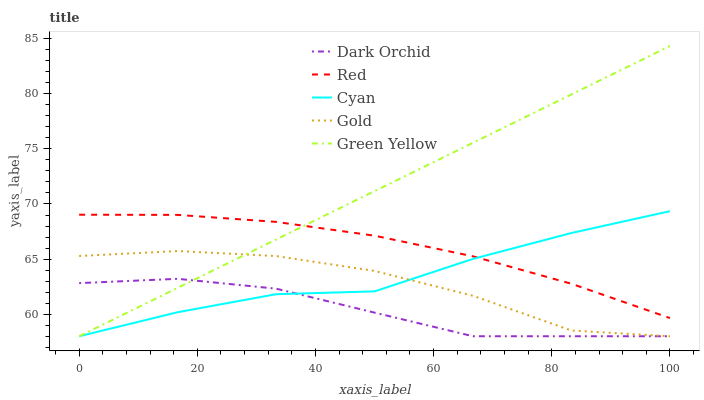Does Dark Orchid have the minimum area under the curve?
Answer yes or no. Yes. Does Green Yellow have the maximum area under the curve?
Answer yes or no. Yes. Does Gold have the minimum area under the curve?
Answer yes or no. No. Does Gold have the maximum area under the curve?
Answer yes or no. No. Is Green Yellow the smoothest?
Answer yes or no. Yes. Is Gold the roughest?
Answer yes or no. Yes. Is Gold the smoothest?
Answer yes or no. No. Is Green Yellow the roughest?
Answer yes or no. No. Does Cyan have the lowest value?
Answer yes or no. Yes. Does Red have the lowest value?
Answer yes or no. No. Does Green Yellow have the highest value?
Answer yes or no. Yes. Does Gold have the highest value?
Answer yes or no. No. Is Gold less than Red?
Answer yes or no. Yes. Is Red greater than Dark Orchid?
Answer yes or no. Yes. Does Dark Orchid intersect Gold?
Answer yes or no. Yes. Is Dark Orchid less than Gold?
Answer yes or no. No. Is Dark Orchid greater than Gold?
Answer yes or no. No. Does Gold intersect Red?
Answer yes or no. No. 